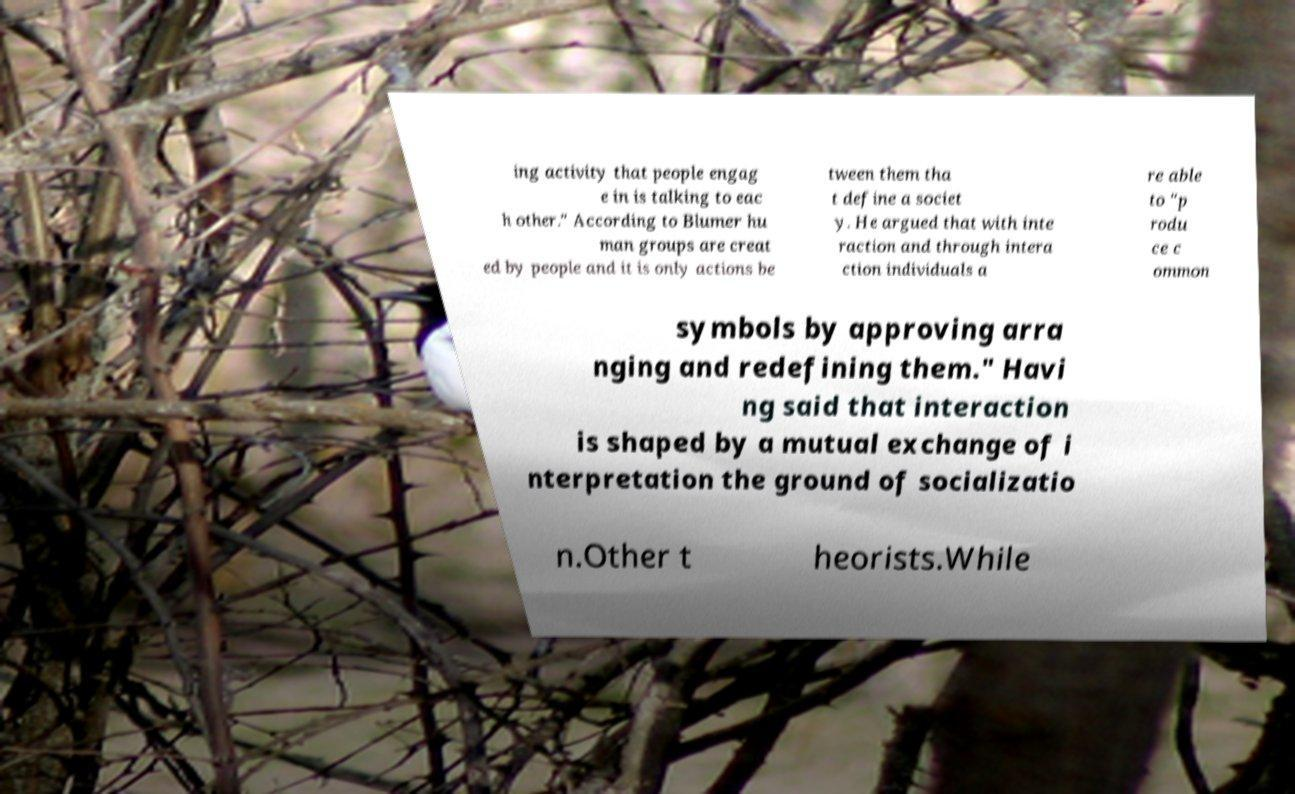Can you accurately transcribe the text from the provided image for me? ing activity that people engag e in is talking to eac h other." According to Blumer hu man groups are creat ed by people and it is only actions be tween them tha t define a societ y. He argued that with inte raction and through intera ction individuals a re able to "p rodu ce c ommon symbols by approving arra nging and redefining them." Havi ng said that interaction is shaped by a mutual exchange of i nterpretation the ground of socializatio n.Other t heorists.While 